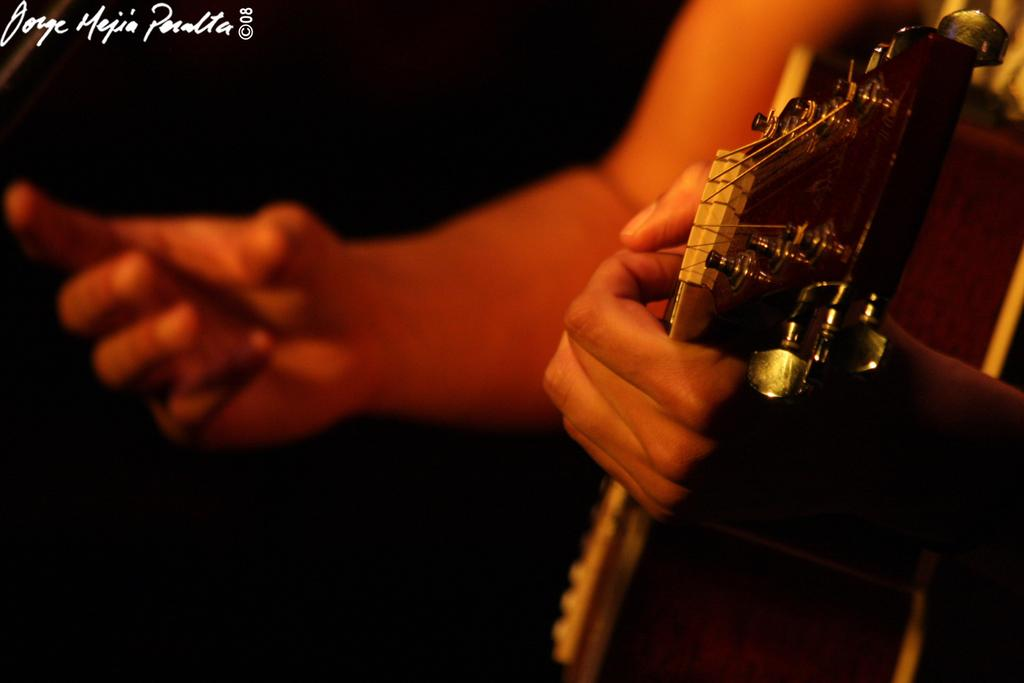Who or what is the main subject in the image? There is a person in the image. What is the person holding in the image? The person is holding a guitar. What type of letters does the governor hold in the image? There is no governor or letters present in the image; it only features a person holding a guitar. 